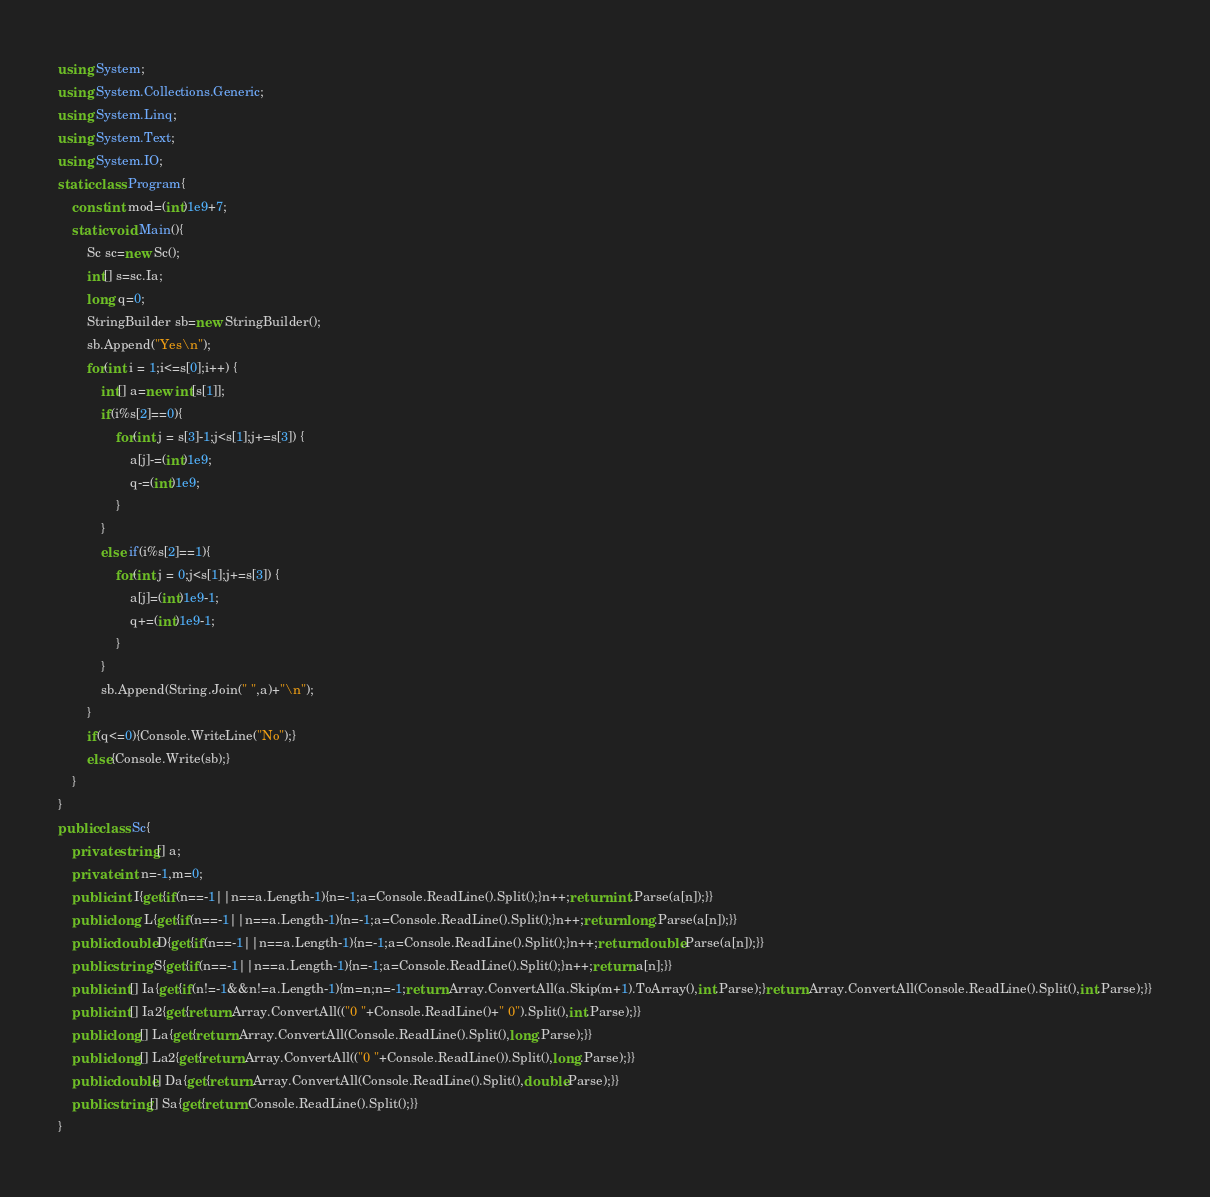Convert code to text. <code><loc_0><loc_0><loc_500><loc_500><_C#_>using System;
using System.Collections.Generic;
using System.Linq;
using System.Text;
using System.IO;
static class Program{
	const int mod=(int)1e9+7;
	static void Main(){
		Sc sc=new Sc();
		int[] s=sc.Ia;
		long q=0;
		StringBuilder sb=new StringBuilder();
		sb.Append("Yes\n");
		for(int i = 1;i<=s[0];i++) {
			int[] a=new int[s[1]];
			if(i%s[2]==0){
				for(int j = s[3]-1;j<s[1];j+=s[3]) {
					a[j]-=(int)1e9;
					q-=(int)1e9;
				}
			}
			else if(i%s[2]==1){
				for(int j = 0;j<s[1];j+=s[3]) {
					a[j]=(int)1e9-1;
					q+=(int)1e9-1;
				}
			}
			sb.Append(String.Join(" ",a)+"\n");
		}
		if(q<=0){Console.WriteLine("No");}
		else{Console.Write(sb);}
	}
}
public class Sc{
	private string[] a;
	private int n=-1,m=0;
	public int I{get{if(n==-1||n==a.Length-1){n=-1;a=Console.ReadLine().Split();}n++;return int.Parse(a[n]);}}
	public long L{get{if(n==-1||n==a.Length-1){n=-1;a=Console.ReadLine().Split();}n++;return long.Parse(a[n]);}}
	public double D{get{if(n==-1||n==a.Length-1){n=-1;a=Console.ReadLine().Split();}n++;return double.Parse(a[n]);}}
	public string S{get{if(n==-1||n==a.Length-1){n=-1;a=Console.ReadLine().Split();}n++;return a[n];}}
	public int[] Ia{get{if(n!=-1&&n!=a.Length-1){m=n;n=-1;return Array.ConvertAll(a.Skip(m+1).ToArray(),int.Parse);}return Array.ConvertAll(Console.ReadLine().Split(),int.Parse);}}
	public int[] Ia2{get{return Array.ConvertAll(("0 "+Console.ReadLine()+" 0").Split(),int.Parse);}}
	public long[] La{get{return Array.ConvertAll(Console.ReadLine().Split(),long.Parse);}}
	public long[] La2{get{return Array.ConvertAll(("0 "+Console.ReadLine()).Split(),long.Parse);}}
	public double[] Da{get{return Array.ConvertAll(Console.ReadLine().Split(),double.Parse);}}
	public string[] Sa{get{return Console.ReadLine().Split();}}
}</code> 